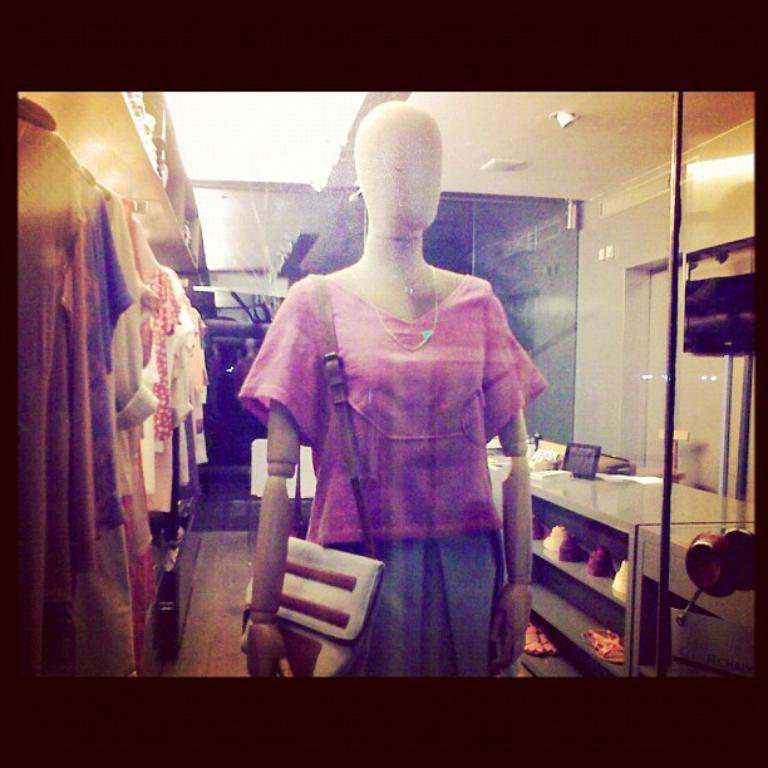What is the main subject in the middle of the image? There is a mannequin in the middle of the image. What is the mannequin wearing? The mannequin is wearing a dress. What is the mannequin holding? The mannequin is holding a handbag. What can be seen in the background of the image? There are many clothes, a TV, snickers, a glass, and lights visible in the background. What type of floor is visible in the image? There is a floor visible in the image. Where is the cat sitting in the image? There is no cat present in the image. What type of glove is the mannequin wearing on its hand? The mannequin is not wearing any gloves in the image. 